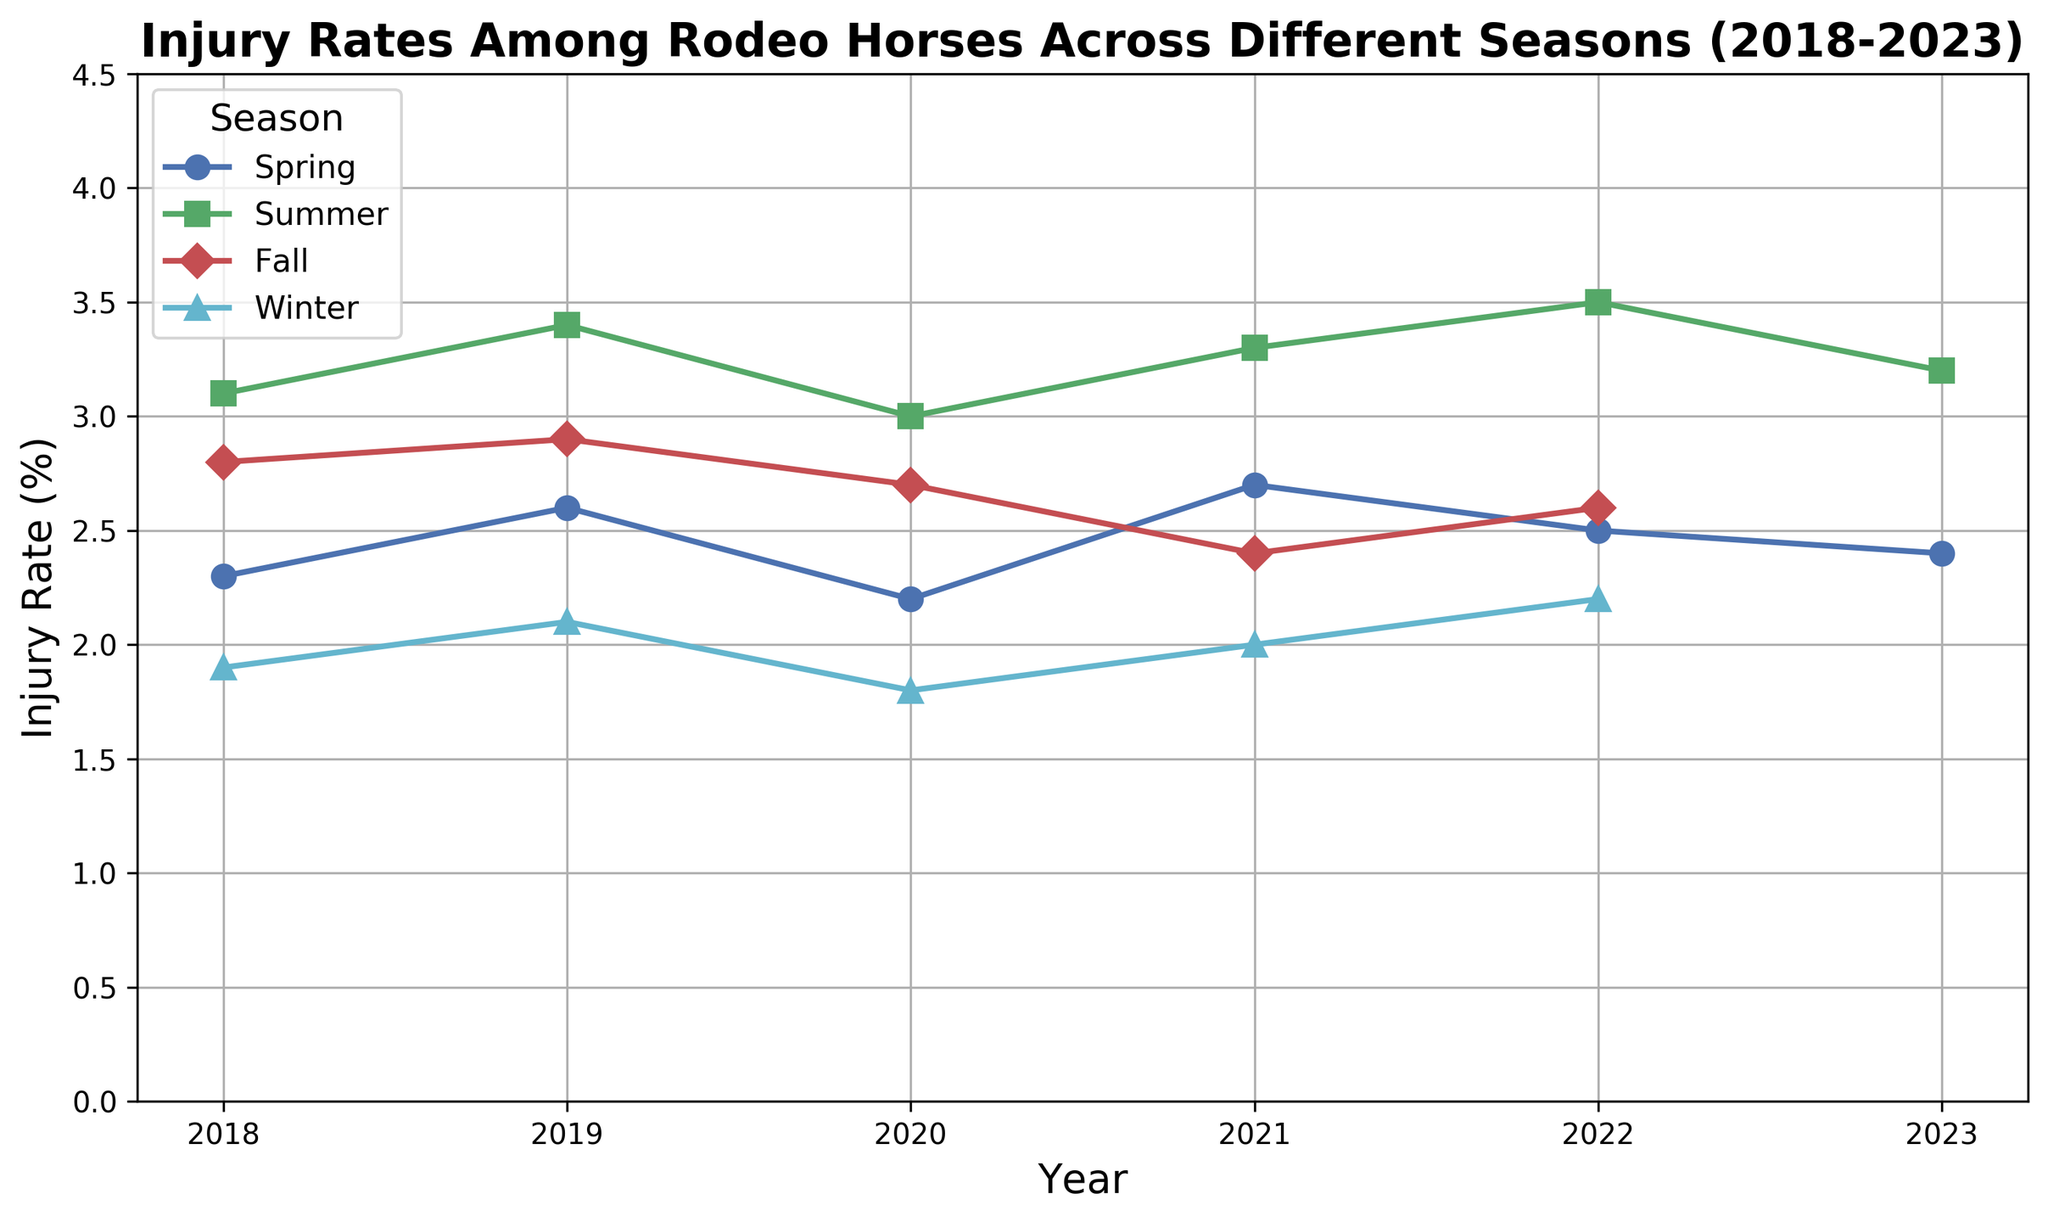What is the injury rate in Winter 2019? Look at the line representing Winter (cyan line with triangles). In 2019, its value is 2.1.
Answer: 2.1 Which season had the highest injury rate in 2022? Compare the points for different seasons in 2022. The Summer season (green line with squares) has the highest value at 3.5.
Answer: Summer How much did the injury rate change from Summer to Winter in 2020? Check the values for Summer and Winter in 2020. Summer is 3.0 and Winter is 1.8. The change is 3.0 - 1.8 = 1.2.
Answer: 1.2 What is the average injury rate for Fall seasons across all years? Look at the Fall data points (red line with diamonds) and calculate the average: (2.8 + 2.9 + 2.7 + 2.4 + 2.6) / 5 = 2.68.
Answer: 2.68 Which year had the lowest injury rate in Spring? Compare the points for Spring (blue line with circles) across all years. The lowest rate is in 2020, which is 2.2.
Answer: 2020 In which season and year was the highest recorded injury rate, and what was the value? Look at all the data points and find the highest one. The highest rate is in Summer 2022 with a value of 3.5.
Answer: Summer 2022, 3.5 Is the injury rate in Fall generally increasing or decreasing from 2018 to 2023? Observe the trend of the Fall line (red line with diamonds) over the years. It starts at 2.8, peaks at 2.9, and then fluctuates downward to 2.6 in 2022.
Answer: Decreasing What is the difference between the highest and lowest injury rates across all seasons and years? First, identify the highest (3.5 in Summer 2022) and lowest (1.8 in Winter 2020) injury rates. Then, calculate the difference: 3.5 - 1.8 = 1.7.
Answer: 1.7 How did the injury rate for Summer 2023 compare to the previous year? Look at the Summer points for 2023 (3.2) and 2022 (3.5). The rate decreased by 3.5 - 3.2 = 0.3.
Answer: Decreased by 0.3 What is the general trend for Winter injury rates from 2018 to 2023? Observe the Winter line (cyan line with triangles) over the years. The rates fluctuate slightly but tend to stay around 2.0 after 2018.
Answer: Generally stable 